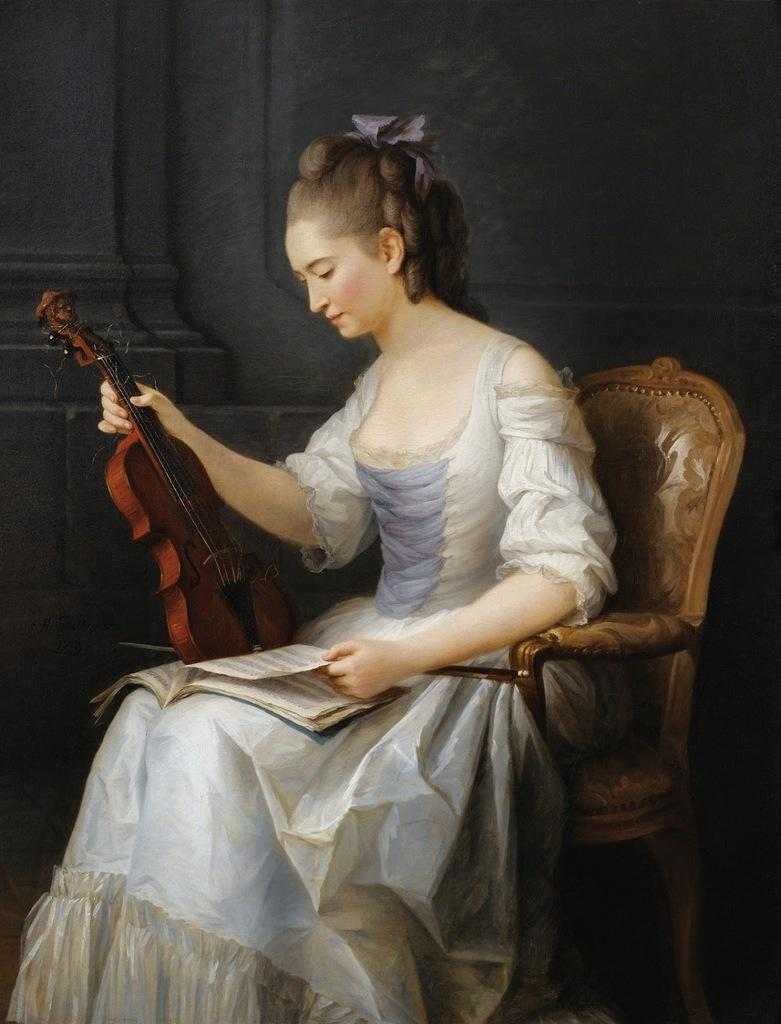Who is the main subject in the image? There is a lady in the image. What is the lady doing in the image? The lady is sitting on a chair. What objects is the lady holding in the image? The lady is holding a book and a violin. What can be seen in the background of the image? There is a wall in the background of the image. What type of stone is the lady using to play the violin in the image? There is no stone present in the image, and the lady is not using any stone to play the violin. 